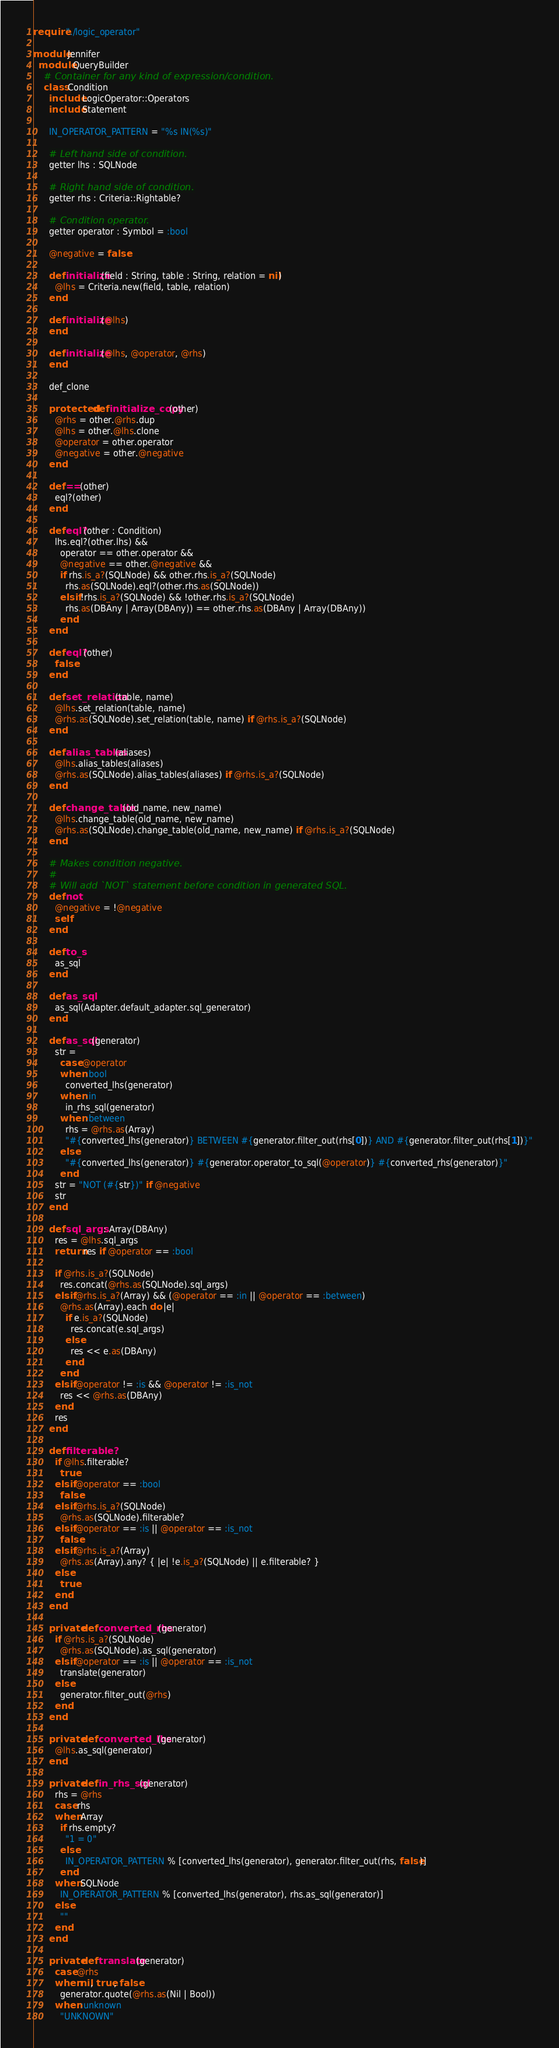<code> <loc_0><loc_0><loc_500><loc_500><_Crystal_>require "./logic_operator"

module Jennifer
  module QueryBuilder
    # Container for any kind of expression/condition.
    class Condition
      include LogicOperator::Operators
      include Statement

      IN_OPERATOR_PATTERN = "%s IN(%s)"

      # Left hand side of condition.
      getter lhs : SQLNode

      # Right hand side of condition.
      getter rhs : Criteria::Rightable?

      # Condition operator.
      getter operator : Symbol = :bool

      @negative = false

      def initialize(field : String, table : String, relation = nil)
        @lhs = Criteria.new(field, table, relation)
      end

      def initialize(@lhs)
      end

      def initialize(@lhs, @operator, @rhs)
      end

      def_clone

      protected def initialize_copy(other)
        @rhs = other.@rhs.dup
        @lhs = other.@lhs.clone
        @operator = other.operator
        @negative = other.@negative
      end

      def ==(other)
        eql?(other)
      end

      def eql?(other : Condition)
        lhs.eql?(other.lhs) &&
          operator == other.operator &&
          @negative == other.@negative &&
          if rhs.is_a?(SQLNode) && other.rhs.is_a?(SQLNode)
            rhs.as(SQLNode).eql?(other.rhs.as(SQLNode))
          elsif !rhs.is_a?(SQLNode) && !other.rhs.is_a?(SQLNode)
            rhs.as(DBAny | Array(DBAny)) == other.rhs.as(DBAny | Array(DBAny))
          end
      end

      def eql?(other)
        false
      end

      def set_relation(table, name)
        @lhs.set_relation(table, name)
        @rhs.as(SQLNode).set_relation(table, name) if @rhs.is_a?(SQLNode)
      end

      def alias_tables(aliases)
        @lhs.alias_tables(aliases)
        @rhs.as(SQLNode).alias_tables(aliases) if @rhs.is_a?(SQLNode)
      end

      def change_table(old_name, new_name)
        @lhs.change_table(old_name, new_name)
        @rhs.as(SQLNode).change_table(old_name, new_name) if @rhs.is_a?(SQLNode)
      end

      # Makes condition negative.
      #
      # Will add `NOT` statement before condition in generated SQL.
      def not
        @negative = !@negative
        self
      end

      def to_s
        as_sql
      end

      def as_sql
        as_sql(Adapter.default_adapter.sql_generator)
      end

      def as_sql(generator)
        str =
          case @operator
          when :bool
            converted_lhs(generator)
          when :in
            in_rhs_sql(generator)
          when :between
            rhs = @rhs.as(Array)
            "#{converted_lhs(generator)} BETWEEN #{generator.filter_out(rhs[0])} AND #{generator.filter_out(rhs[1])}"
          else
            "#{converted_lhs(generator)} #{generator.operator_to_sql(@operator)} #{converted_rhs(generator)}"
          end
        str = "NOT (#{str})" if @negative
        str
      end

      def sql_args : Array(DBAny)
        res = @lhs.sql_args
        return res if @operator == :bool

        if @rhs.is_a?(SQLNode)
          res.concat(@rhs.as(SQLNode).sql_args)
        elsif @rhs.is_a?(Array) && (@operator == :in || @operator == :between)
          @rhs.as(Array).each do |e|
            if e.is_a?(SQLNode)
              res.concat(e.sql_args)
            else
              res << e.as(DBAny)
            end
          end
        elsif @operator != :is && @operator != :is_not
          res << @rhs.as(DBAny)
        end
        res
      end

      def filterable?
        if @lhs.filterable?
          true
        elsif @operator == :bool
          false
        elsif @rhs.is_a?(SQLNode)
          @rhs.as(SQLNode).filterable?
        elsif @operator == :is || @operator == :is_not
          false
        elsif @rhs.is_a?(Array)
          @rhs.as(Array).any? { |e| !e.is_a?(SQLNode) || e.filterable? }
        else
          true
        end
      end

      private def converted_rhs(generator)
        if @rhs.is_a?(SQLNode)
          @rhs.as(SQLNode).as_sql(generator)
        elsif @operator == :is || @operator == :is_not
          translate(generator)
        else
          generator.filter_out(@rhs)
        end
      end

      private def converted_lhs(generator)
        @lhs.as_sql(generator)
      end

      private def in_rhs_sql(generator)
        rhs = @rhs
        case rhs
        when Array
          if rhs.empty?
            "1 = 0"
          else
            IN_OPERATOR_PATTERN % [converted_lhs(generator), generator.filter_out(rhs, false)]
          end
        when SQLNode
          IN_OPERATOR_PATTERN % [converted_lhs(generator), rhs.as_sql(generator)]
        else
          ""
        end
      end

      private def translate(generator)
        case @rhs
        when nil, true, false
          generator.quote(@rhs.as(Nil | Bool))
        when :unknown
          "UNKNOWN"</code> 